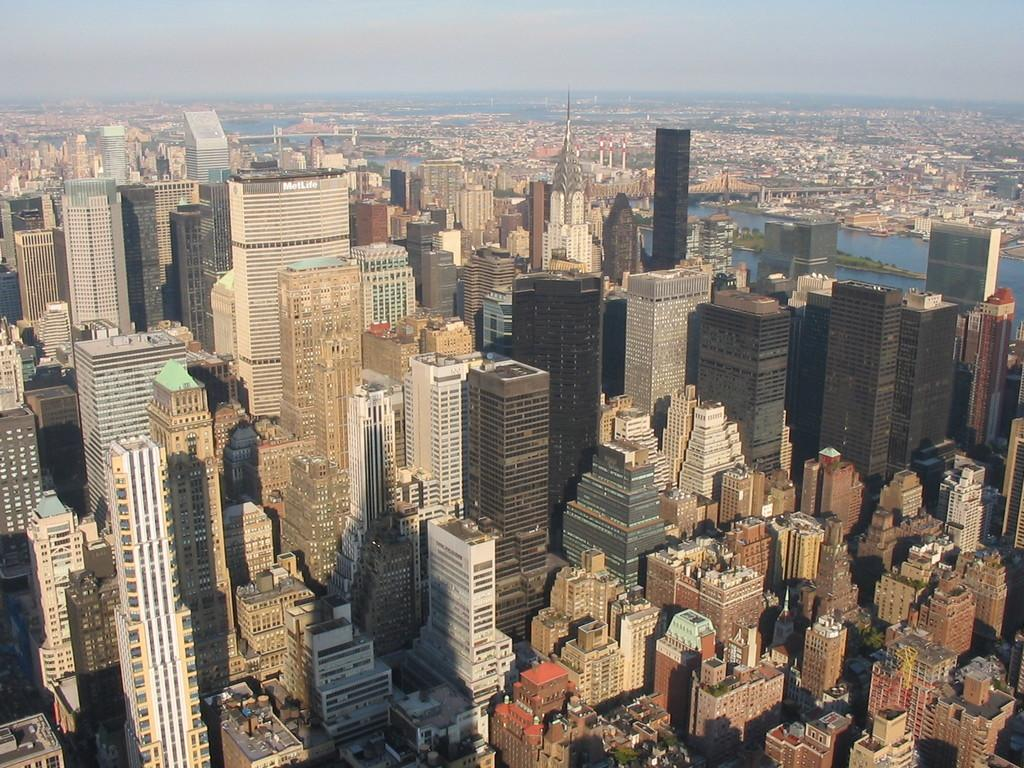What type of structures can be seen in the image? There are buildings in the image. What natural feature is present on the right side of the image? There is a river on the right side of the image. What is visible at the top of the image? The sky is visible at the top of the image. What type of song is being sung by the river in the image? There is no indication of a song being sung in the image; it features buildings, a river, and the sky. What disease might be affecting the buildings in the image? There is no indication of any disease affecting the buildings in the image; they appear to be standing normally. 